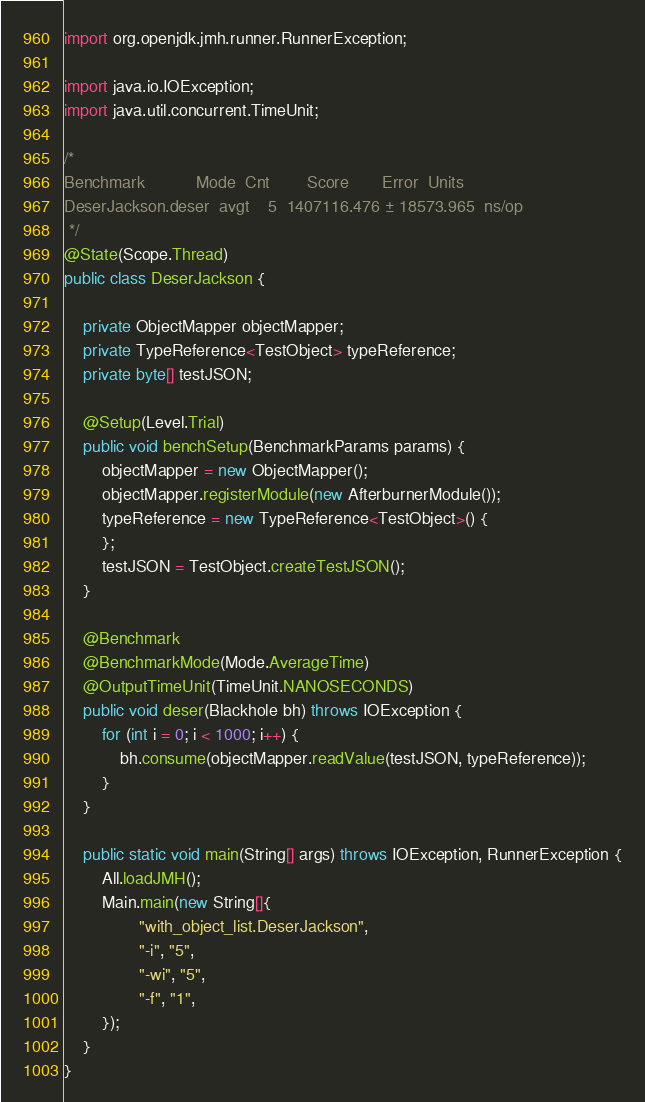Convert code to text. <code><loc_0><loc_0><loc_500><loc_500><_Java_>import org.openjdk.jmh.runner.RunnerException;

import java.io.IOException;
import java.util.concurrent.TimeUnit;

/*
Benchmark           Mode  Cnt        Score       Error  Units
DeserJackson.deser  avgt    5  1407116.476 ± 18573.965  ns/op
 */
@State(Scope.Thread)
public class DeserJackson {

    private ObjectMapper objectMapper;
    private TypeReference<TestObject> typeReference;
    private byte[] testJSON;

    @Setup(Level.Trial)
    public void benchSetup(BenchmarkParams params) {
        objectMapper = new ObjectMapper();
        objectMapper.registerModule(new AfterburnerModule());
        typeReference = new TypeReference<TestObject>() {
        };
        testJSON = TestObject.createTestJSON();
    }

    @Benchmark
    @BenchmarkMode(Mode.AverageTime)
    @OutputTimeUnit(TimeUnit.NANOSECONDS)
    public void deser(Blackhole bh) throws IOException {
        for (int i = 0; i < 1000; i++) {
            bh.consume(objectMapper.readValue(testJSON, typeReference));
        }
    }

    public static void main(String[] args) throws IOException, RunnerException {
        All.loadJMH();
        Main.main(new String[]{
                "with_object_list.DeserJackson",
                "-i", "5",
                "-wi", "5",
                "-f", "1",
        });
    }
}
</code> 